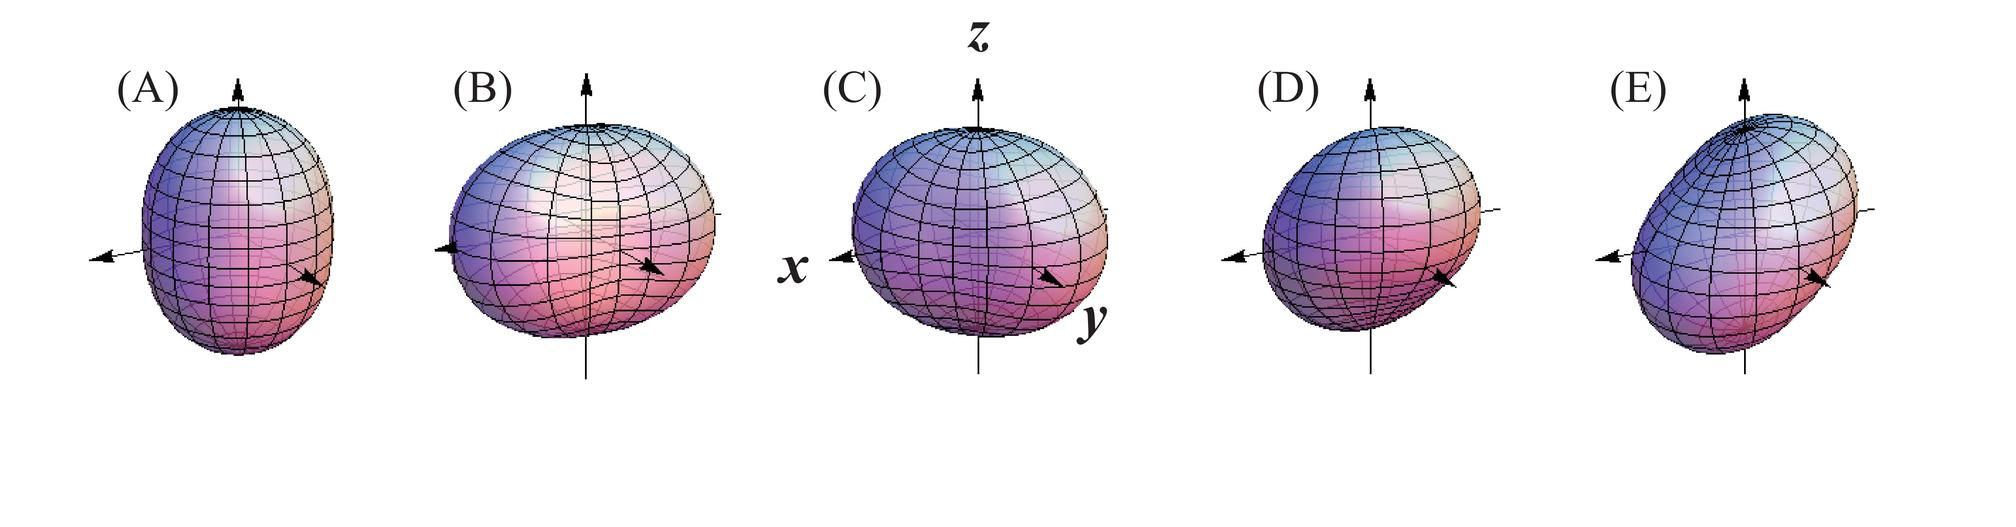Can you describe the process taking place in figure A and how it differs from figure E? Figure A shows a spherical object with forces applied uniformly from two opposite directions, resulting in compression along one axis. Contrastingly, figure E depicts an object experiencing an uneven force leading to an elongated deformation and a more pronounced distortion. Essentially, figure A demonstrates symmetrical compression, whereas figure E exhibits asymmetric stretching of the object. 